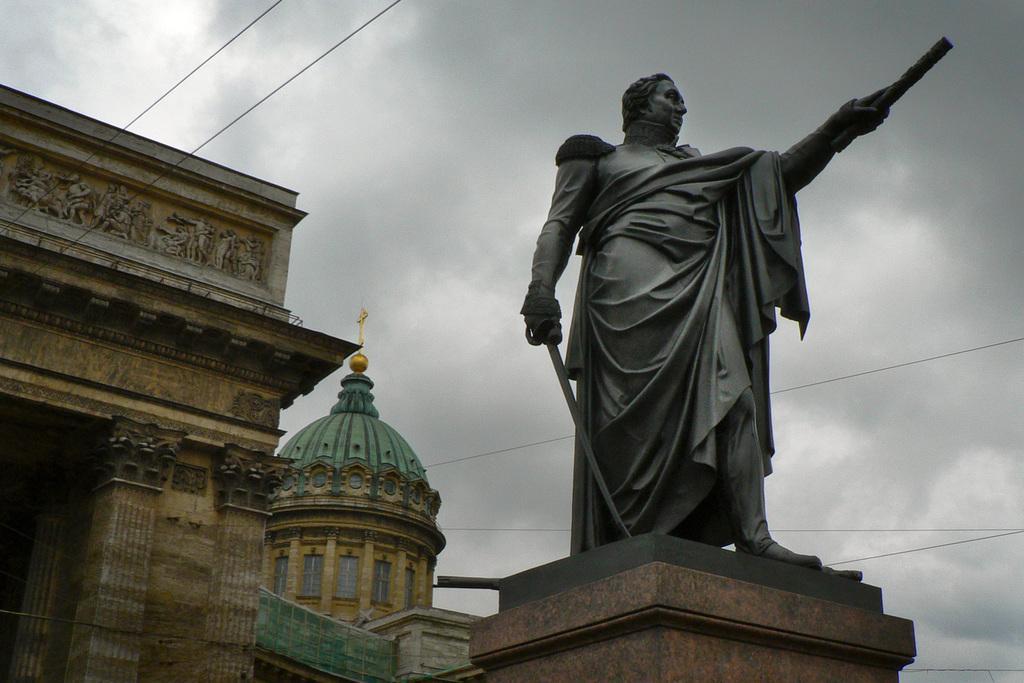Please provide a concise description of this image. In this picture we can see a statue of a man, buildings, wires and in the background we can see the sky with clouds. 